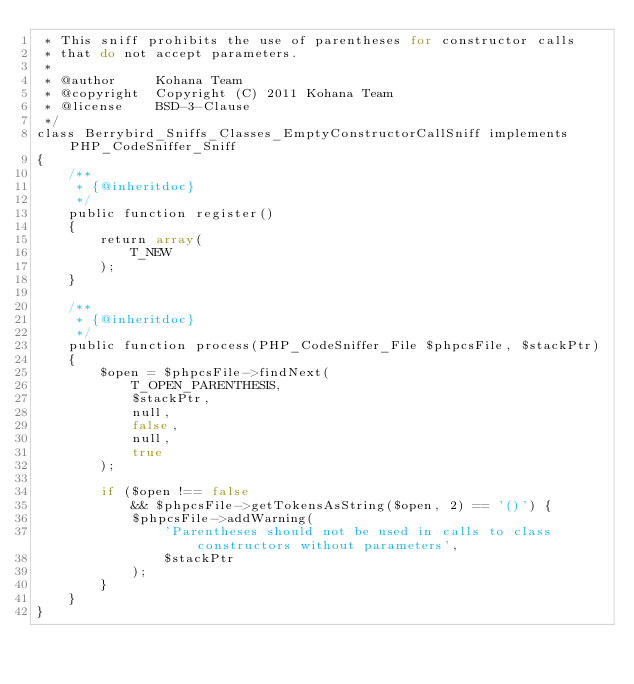Convert code to text. <code><loc_0><loc_0><loc_500><loc_500><_PHP_> * This sniff prohibits the use of parentheses for constructor calls
 * that do not accept parameters.
 *
 * @author     Kohana Team
 * @copyright  Copyright (C) 2011 Kohana Team
 * @license    BSD-3-Clause
 */
class Berrybird_Sniffs_Classes_EmptyConstructorCallSniff implements PHP_CodeSniffer_Sniff
{
    /**
     * {@inheritdoc}
     */
    public function register()
    {
        return array(
            T_NEW
        );
    }

    /**
     * {@inheritdoc}
     */
    public function process(PHP_CodeSniffer_File $phpcsFile, $stackPtr)
    {
        $open = $phpcsFile->findNext(
            T_OPEN_PARENTHESIS,
            $stackPtr,
            null,
            false,
            null,
            true
        );

        if ($open !== false
            && $phpcsFile->getTokensAsString($open, 2) == '()') {
            $phpcsFile->addWarning(
                'Parentheses should not be used in calls to class constructors without parameters',
                $stackPtr
            );
        }
    }
}
</code> 